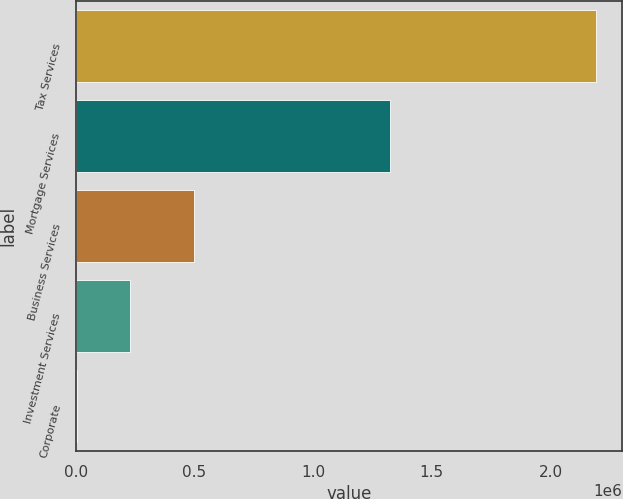Convert chart. <chart><loc_0><loc_0><loc_500><loc_500><bar_chart><fcel>Tax Services<fcel>Mortgage Services<fcel>Business Services<fcel>Investment Services<fcel>Corporate<nl><fcel>2.19118e+06<fcel>1.32371e+06<fcel>499210<fcel>229470<fcel>4314<nl></chart> 